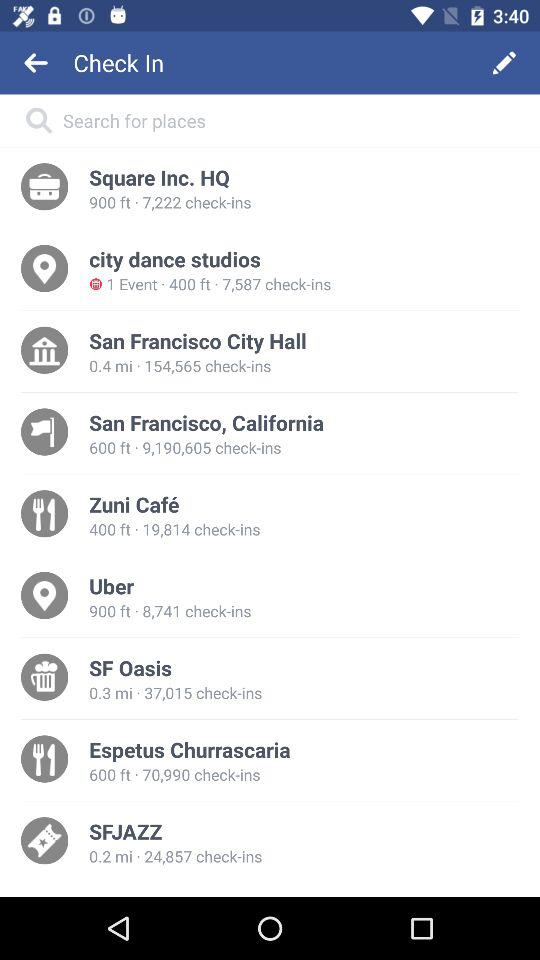How many people check-in at Uber? There are 8,741 people who check-in at Uber. 